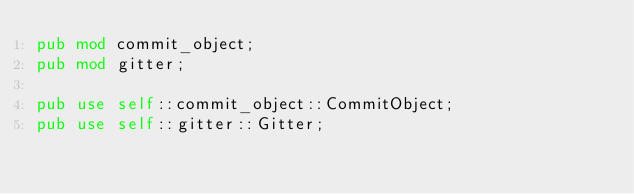<code> <loc_0><loc_0><loc_500><loc_500><_Rust_>pub mod commit_object;
pub mod gitter;

pub use self::commit_object::CommitObject;
pub use self::gitter::Gitter;
</code> 